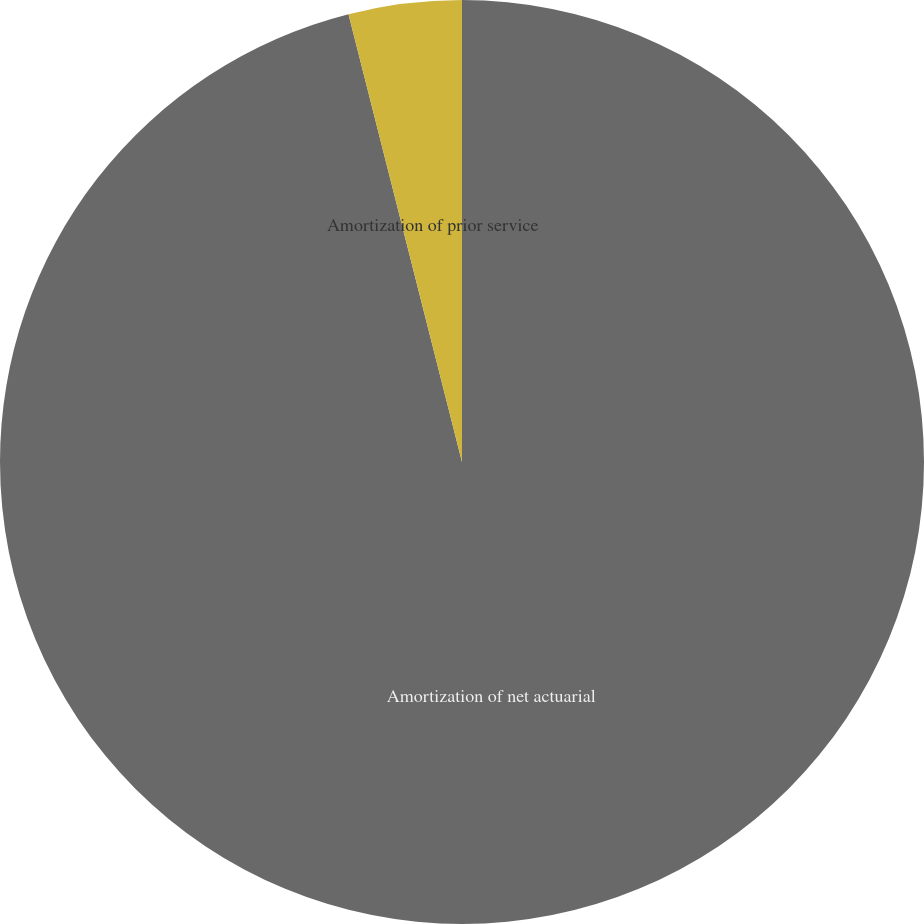Convert chart to OTSL. <chart><loc_0><loc_0><loc_500><loc_500><pie_chart><fcel>Amortization of net actuarial<fcel>Amortization of prior service<nl><fcel>96.05%<fcel>3.95%<nl></chart> 